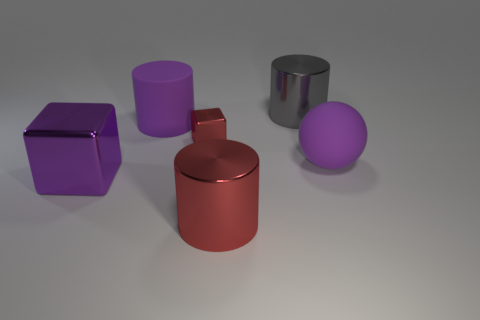Is there a brown cylinder that has the same material as the big red object?
Provide a succinct answer. No. The matte thing that is the same color as the big matte ball is what shape?
Make the answer very short. Cylinder. What color is the block on the left side of the red block?
Keep it short and to the point. Purple. Is the number of large shiny cubes to the left of the purple metallic thing the same as the number of purple shiny things right of the large purple rubber cylinder?
Provide a succinct answer. Yes. What is the material of the purple thing on the right side of the cube that is right of the purple cube?
Your answer should be very brief. Rubber. What number of things are purple shiny things or objects that are behind the red metal cylinder?
Your answer should be compact. 5. There is a gray thing that is the same material as the large purple block; what is its size?
Give a very brief answer. Large. Is the number of purple rubber things that are left of the big red shiny cylinder greater than the number of small purple spheres?
Offer a very short reply. Yes. There is a cylinder that is behind the big metal block and right of the small red cube; what size is it?
Offer a terse response. Large. There is a red thing that is the same shape as the purple shiny object; what is it made of?
Provide a succinct answer. Metal. 